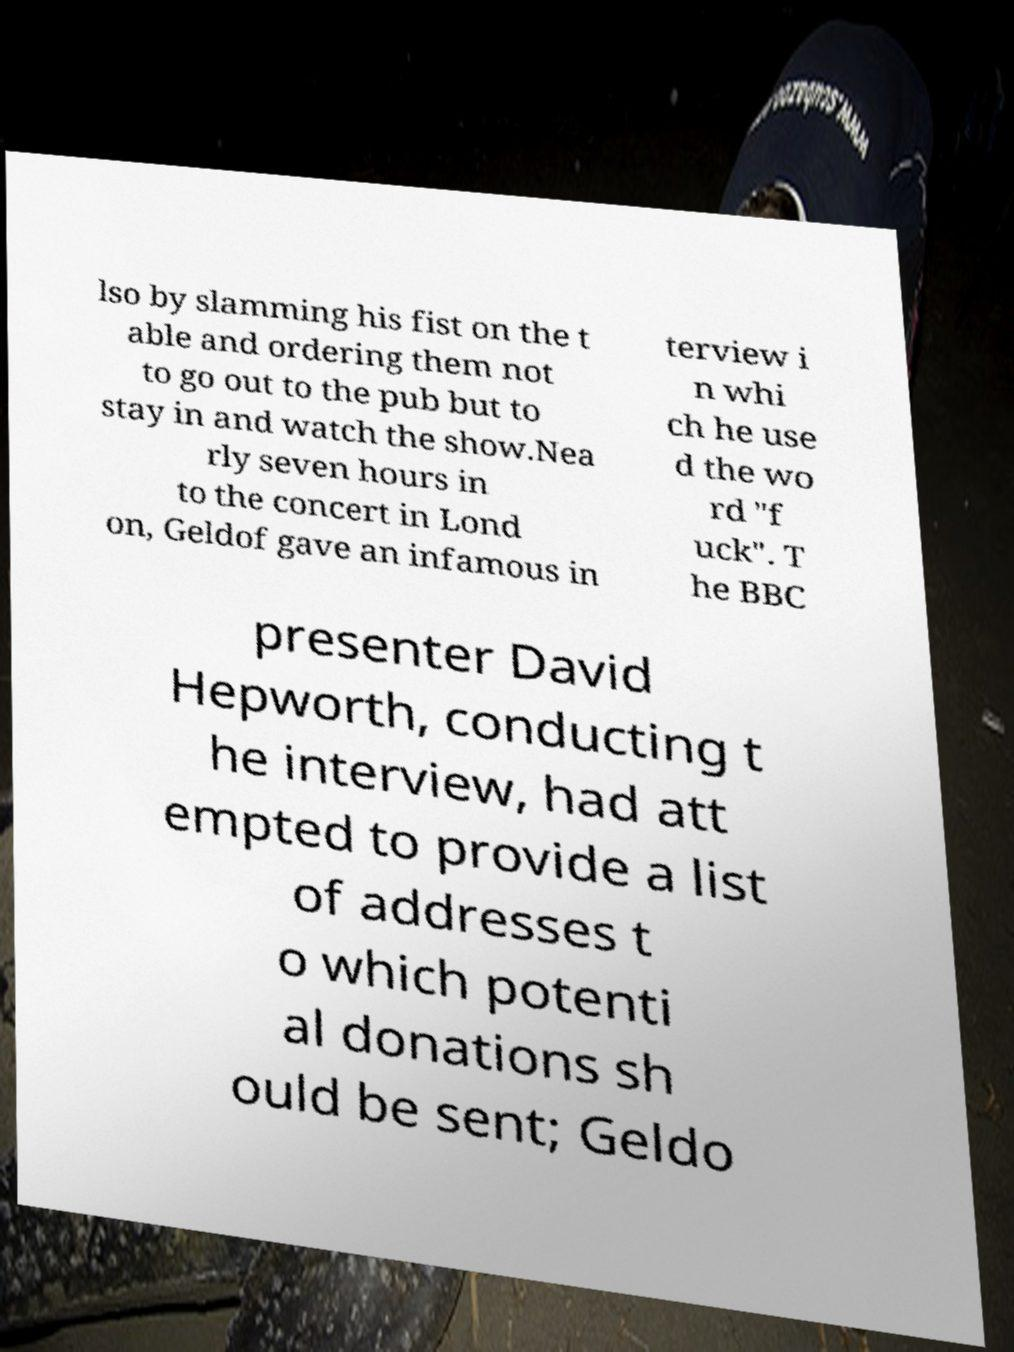What messages or text are displayed in this image? I need them in a readable, typed format. lso by slamming his fist on the t able and ordering them not to go out to the pub but to stay in and watch the show.Nea rly seven hours in to the concert in Lond on, Geldof gave an infamous in terview i n whi ch he use d the wo rd "f uck". T he BBC presenter David Hepworth, conducting t he interview, had att empted to provide a list of addresses t o which potenti al donations sh ould be sent; Geldo 